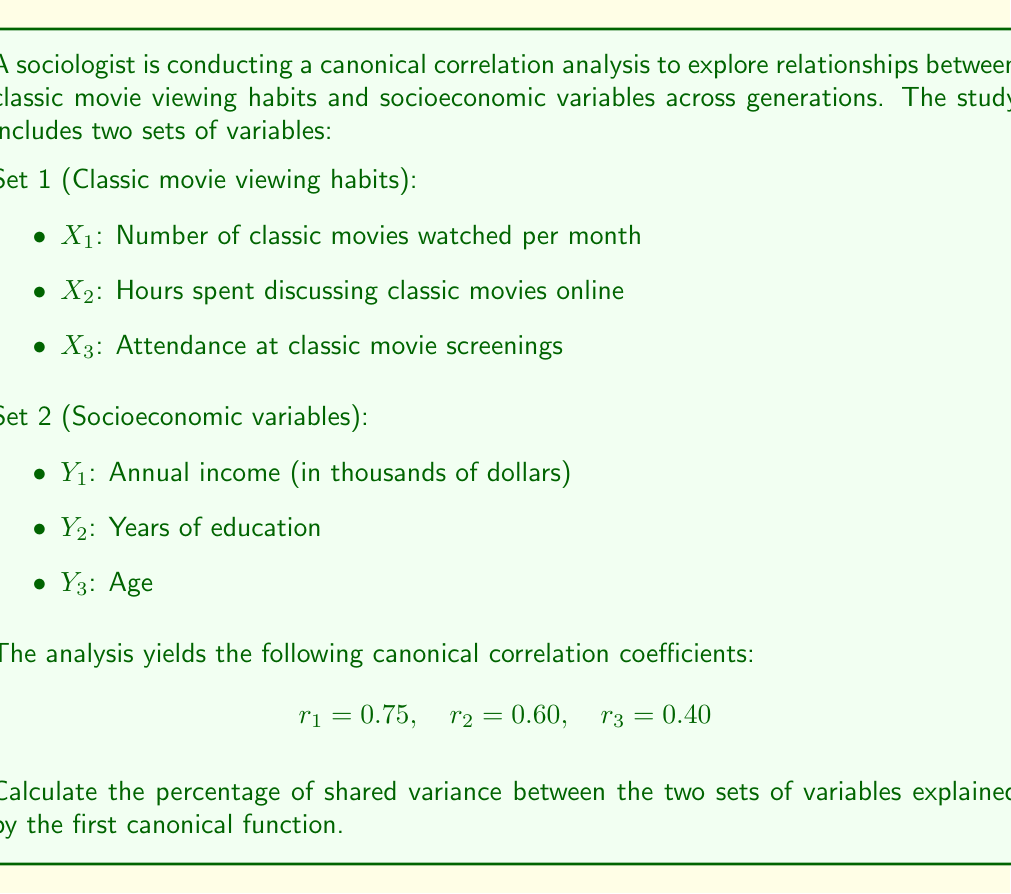Teach me how to tackle this problem. To solve this problem, we need to understand the concept of shared variance in canonical correlation analysis and how to calculate it using the canonical correlation coefficients.

1. In canonical correlation analysis, the shared variance between two sets of variables is represented by the squared canonical correlation coefficient.

2. The total shared variance is the sum of the squared canonical correlation coefficients for all canonical functions.

3. To calculate the percentage of shared variance explained by the first canonical function, we need to:
   a. Square the first canonical correlation coefficient
   b. Calculate the sum of all squared canonical correlation coefficients
   c. Divide the result from step (a) by the result from step (b) and multiply by 100

Let's perform these steps:

a. Square the first canonical correlation coefficient:
   $r_1^2 = 0.75^2 = 0.5625$

b. Calculate the sum of all squared canonical correlation coefficients:
   $\sum r_i^2 = r_1^2 + r_2^2 + r_3^2$
   $\sum r_i^2 = 0.75^2 + 0.60^2 + 0.40^2$
   $\sum r_i^2 = 0.5625 + 0.3600 + 0.1600 = 1.0825$

c. Calculate the percentage of shared variance explained by the first canonical function:
   $\text{Percentage} = \frac{r_1^2}{\sum r_i^2} \times 100\%$
   $\text{Percentage} = \frac{0.5625}{1.0825} \times 100\% \approx 51.96\%$

Therefore, the first canonical function explains approximately 51.96% of the shared variance between the classic movie viewing habits and socioeconomic variables across generations.
Answer: 51.96% 